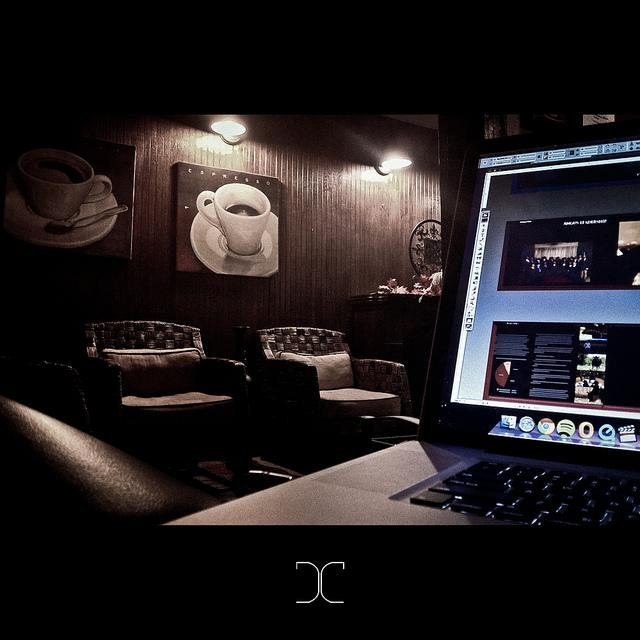What company is the main competitor to the laptop's operating system? microsoft 